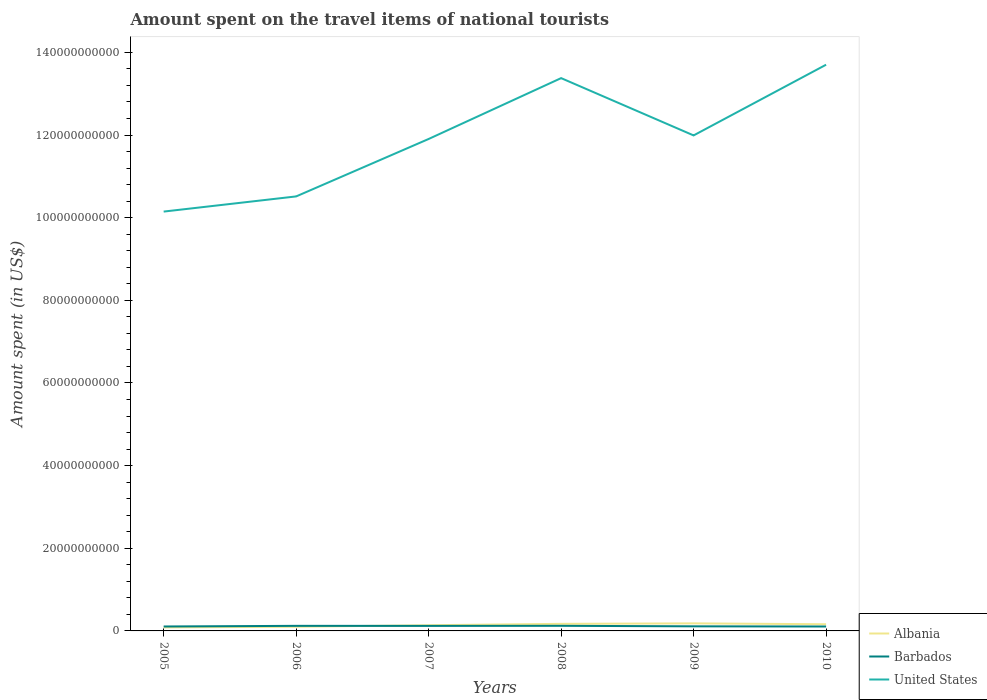Across all years, what is the maximum amount spent on the travel items of national tourists in Barbados?
Make the answer very short. 1.07e+09. In which year was the amount spent on the travel items of national tourists in Barbados maximum?
Offer a terse response. 2010. What is the total amount spent on the travel items of national tourists in Barbados in the graph?
Offer a very short reply. -1.44e+08. What is the difference between the highest and the second highest amount spent on the travel items of national tourists in United States?
Provide a short and direct response. 3.55e+1. How many years are there in the graph?
Your answer should be compact. 6. Does the graph contain any zero values?
Ensure brevity in your answer.  No. How many legend labels are there?
Your answer should be very brief. 3. How are the legend labels stacked?
Keep it short and to the point. Vertical. What is the title of the graph?
Your response must be concise. Amount spent on the travel items of national tourists. What is the label or title of the Y-axis?
Your response must be concise. Amount spent (in US$). What is the Amount spent (in US$) in Albania in 2005?
Make the answer very short. 8.54e+08. What is the Amount spent (in US$) of Barbados in 2005?
Provide a short and direct response. 1.07e+09. What is the Amount spent (in US$) of United States in 2005?
Your response must be concise. 1.01e+11. What is the Amount spent (in US$) of Albania in 2006?
Give a very brief answer. 1.01e+09. What is the Amount spent (in US$) of Barbados in 2006?
Keep it short and to the point. 1.23e+09. What is the Amount spent (in US$) of United States in 2006?
Provide a succinct answer. 1.05e+11. What is the Amount spent (in US$) of Albania in 2007?
Provide a short and direct response. 1.38e+09. What is the Amount spent (in US$) of Barbados in 2007?
Offer a very short reply. 1.22e+09. What is the Amount spent (in US$) in United States in 2007?
Keep it short and to the point. 1.19e+11. What is the Amount spent (in US$) of Albania in 2008?
Ensure brevity in your answer.  1.71e+09. What is the Amount spent (in US$) of Barbados in 2008?
Your answer should be compact. 1.24e+09. What is the Amount spent (in US$) of United States in 2008?
Offer a very short reply. 1.34e+11. What is the Amount spent (in US$) of Albania in 2009?
Offer a terse response. 1.83e+09. What is the Amount spent (in US$) of Barbados in 2009?
Give a very brief answer. 1.11e+09. What is the Amount spent (in US$) in United States in 2009?
Provide a succinct answer. 1.20e+11. What is the Amount spent (in US$) of Albania in 2010?
Your answer should be compact. 1.61e+09. What is the Amount spent (in US$) of Barbados in 2010?
Give a very brief answer. 1.07e+09. What is the Amount spent (in US$) of United States in 2010?
Keep it short and to the point. 1.37e+11. Across all years, what is the maximum Amount spent (in US$) of Albania?
Offer a very short reply. 1.83e+09. Across all years, what is the maximum Amount spent (in US$) in Barbados?
Give a very brief answer. 1.24e+09. Across all years, what is the maximum Amount spent (in US$) of United States?
Make the answer very short. 1.37e+11. Across all years, what is the minimum Amount spent (in US$) of Albania?
Make the answer very short. 8.54e+08. Across all years, what is the minimum Amount spent (in US$) of Barbados?
Provide a succinct answer. 1.07e+09. Across all years, what is the minimum Amount spent (in US$) of United States?
Provide a succinct answer. 1.01e+11. What is the total Amount spent (in US$) of Albania in the graph?
Provide a short and direct response. 8.40e+09. What is the total Amount spent (in US$) of Barbados in the graph?
Ensure brevity in your answer.  6.94e+09. What is the total Amount spent (in US$) in United States in the graph?
Provide a succinct answer. 7.16e+11. What is the difference between the Amount spent (in US$) of Albania in 2005 and that in 2006?
Offer a very short reply. -1.58e+08. What is the difference between the Amount spent (in US$) in Barbados in 2005 and that in 2006?
Offer a terse response. -1.55e+08. What is the difference between the Amount spent (in US$) of United States in 2005 and that in 2006?
Provide a short and direct response. -3.67e+09. What is the difference between the Amount spent (in US$) of Albania in 2005 and that in 2007?
Your answer should be very brief. -5.24e+08. What is the difference between the Amount spent (in US$) of Barbados in 2005 and that in 2007?
Keep it short and to the point. -1.44e+08. What is the difference between the Amount spent (in US$) of United States in 2005 and that in 2007?
Your answer should be very brief. -1.76e+1. What is the difference between the Amount spent (in US$) of Albania in 2005 and that in 2008?
Your response must be concise. -8.59e+08. What is the difference between the Amount spent (in US$) in Barbados in 2005 and that in 2008?
Offer a terse response. -1.64e+08. What is the difference between the Amount spent (in US$) of United States in 2005 and that in 2008?
Give a very brief answer. -3.23e+1. What is the difference between the Amount spent (in US$) in Albania in 2005 and that in 2009?
Keep it short and to the point. -9.75e+08. What is the difference between the Amount spent (in US$) in Barbados in 2005 and that in 2009?
Your answer should be compact. -3.90e+07. What is the difference between the Amount spent (in US$) in United States in 2005 and that in 2009?
Your answer should be very brief. -1.84e+1. What is the difference between the Amount spent (in US$) of Albania in 2005 and that in 2010?
Give a very brief answer. -7.59e+08. What is the difference between the Amount spent (in US$) in United States in 2005 and that in 2010?
Keep it short and to the point. -3.55e+1. What is the difference between the Amount spent (in US$) of Albania in 2006 and that in 2007?
Keep it short and to the point. -3.66e+08. What is the difference between the Amount spent (in US$) in Barbados in 2006 and that in 2007?
Make the answer very short. 1.10e+07. What is the difference between the Amount spent (in US$) in United States in 2006 and that in 2007?
Provide a succinct answer. -1.39e+1. What is the difference between the Amount spent (in US$) of Albania in 2006 and that in 2008?
Your answer should be compact. -7.01e+08. What is the difference between the Amount spent (in US$) in Barbados in 2006 and that in 2008?
Offer a terse response. -9.00e+06. What is the difference between the Amount spent (in US$) in United States in 2006 and that in 2008?
Keep it short and to the point. -2.86e+1. What is the difference between the Amount spent (in US$) in Albania in 2006 and that in 2009?
Keep it short and to the point. -8.17e+08. What is the difference between the Amount spent (in US$) of Barbados in 2006 and that in 2009?
Make the answer very short. 1.16e+08. What is the difference between the Amount spent (in US$) of United States in 2006 and that in 2009?
Give a very brief answer. -1.48e+1. What is the difference between the Amount spent (in US$) of Albania in 2006 and that in 2010?
Make the answer very short. -6.01e+08. What is the difference between the Amount spent (in US$) in Barbados in 2006 and that in 2010?
Your answer should be compact. 1.57e+08. What is the difference between the Amount spent (in US$) in United States in 2006 and that in 2010?
Give a very brief answer. -3.19e+1. What is the difference between the Amount spent (in US$) of Albania in 2007 and that in 2008?
Offer a terse response. -3.35e+08. What is the difference between the Amount spent (in US$) in Barbados in 2007 and that in 2008?
Offer a very short reply. -2.00e+07. What is the difference between the Amount spent (in US$) in United States in 2007 and that in 2008?
Offer a terse response. -1.47e+1. What is the difference between the Amount spent (in US$) in Albania in 2007 and that in 2009?
Provide a short and direct response. -4.51e+08. What is the difference between the Amount spent (in US$) of Barbados in 2007 and that in 2009?
Your response must be concise. 1.05e+08. What is the difference between the Amount spent (in US$) in United States in 2007 and that in 2009?
Give a very brief answer. -8.63e+08. What is the difference between the Amount spent (in US$) of Albania in 2007 and that in 2010?
Ensure brevity in your answer.  -2.35e+08. What is the difference between the Amount spent (in US$) of Barbados in 2007 and that in 2010?
Your answer should be compact. 1.46e+08. What is the difference between the Amount spent (in US$) in United States in 2007 and that in 2010?
Keep it short and to the point. -1.80e+1. What is the difference between the Amount spent (in US$) in Albania in 2008 and that in 2009?
Give a very brief answer. -1.16e+08. What is the difference between the Amount spent (in US$) of Barbados in 2008 and that in 2009?
Ensure brevity in your answer.  1.25e+08. What is the difference between the Amount spent (in US$) of United States in 2008 and that in 2009?
Offer a very short reply. 1.39e+1. What is the difference between the Amount spent (in US$) of Albania in 2008 and that in 2010?
Your answer should be compact. 1.00e+08. What is the difference between the Amount spent (in US$) of Barbados in 2008 and that in 2010?
Keep it short and to the point. 1.66e+08. What is the difference between the Amount spent (in US$) of United States in 2008 and that in 2010?
Keep it short and to the point. -3.24e+09. What is the difference between the Amount spent (in US$) of Albania in 2009 and that in 2010?
Ensure brevity in your answer.  2.16e+08. What is the difference between the Amount spent (in US$) in Barbados in 2009 and that in 2010?
Your response must be concise. 4.10e+07. What is the difference between the Amount spent (in US$) of United States in 2009 and that in 2010?
Make the answer very short. -1.71e+1. What is the difference between the Amount spent (in US$) of Albania in 2005 and the Amount spent (in US$) of Barbados in 2006?
Keep it short and to the point. -3.74e+08. What is the difference between the Amount spent (in US$) of Albania in 2005 and the Amount spent (in US$) of United States in 2006?
Offer a terse response. -1.04e+11. What is the difference between the Amount spent (in US$) in Barbados in 2005 and the Amount spent (in US$) in United States in 2006?
Your response must be concise. -1.04e+11. What is the difference between the Amount spent (in US$) in Albania in 2005 and the Amount spent (in US$) in Barbados in 2007?
Provide a succinct answer. -3.63e+08. What is the difference between the Amount spent (in US$) of Albania in 2005 and the Amount spent (in US$) of United States in 2007?
Provide a succinct answer. -1.18e+11. What is the difference between the Amount spent (in US$) in Barbados in 2005 and the Amount spent (in US$) in United States in 2007?
Make the answer very short. -1.18e+11. What is the difference between the Amount spent (in US$) in Albania in 2005 and the Amount spent (in US$) in Barbados in 2008?
Your response must be concise. -3.83e+08. What is the difference between the Amount spent (in US$) of Albania in 2005 and the Amount spent (in US$) of United States in 2008?
Your answer should be compact. -1.33e+11. What is the difference between the Amount spent (in US$) of Barbados in 2005 and the Amount spent (in US$) of United States in 2008?
Provide a succinct answer. -1.33e+11. What is the difference between the Amount spent (in US$) in Albania in 2005 and the Amount spent (in US$) in Barbados in 2009?
Offer a terse response. -2.58e+08. What is the difference between the Amount spent (in US$) in Albania in 2005 and the Amount spent (in US$) in United States in 2009?
Make the answer very short. -1.19e+11. What is the difference between the Amount spent (in US$) in Barbados in 2005 and the Amount spent (in US$) in United States in 2009?
Provide a succinct answer. -1.19e+11. What is the difference between the Amount spent (in US$) of Albania in 2005 and the Amount spent (in US$) of Barbados in 2010?
Provide a succinct answer. -2.17e+08. What is the difference between the Amount spent (in US$) of Albania in 2005 and the Amount spent (in US$) of United States in 2010?
Offer a terse response. -1.36e+11. What is the difference between the Amount spent (in US$) in Barbados in 2005 and the Amount spent (in US$) in United States in 2010?
Provide a short and direct response. -1.36e+11. What is the difference between the Amount spent (in US$) in Albania in 2006 and the Amount spent (in US$) in Barbados in 2007?
Keep it short and to the point. -2.05e+08. What is the difference between the Amount spent (in US$) of Albania in 2006 and the Amount spent (in US$) of United States in 2007?
Provide a succinct answer. -1.18e+11. What is the difference between the Amount spent (in US$) in Barbados in 2006 and the Amount spent (in US$) in United States in 2007?
Provide a succinct answer. -1.18e+11. What is the difference between the Amount spent (in US$) of Albania in 2006 and the Amount spent (in US$) of Barbados in 2008?
Give a very brief answer. -2.25e+08. What is the difference between the Amount spent (in US$) of Albania in 2006 and the Amount spent (in US$) of United States in 2008?
Make the answer very short. -1.33e+11. What is the difference between the Amount spent (in US$) in Barbados in 2006 and the Amount spent (in US$) in United States in 2008?
Your answer should be compact. -1.33e+11. What is the difference between the Amount spent (in US$) in Albania in 2006 and the Amount spent (in US$) in Barbados in 2009?
Provide a succinct answer. -1.00e+08. What is the difference between the Amount spent (in US$) in Albania in 2006 and the Amount spent (in US$) in United States in 2009?
Make the answer very short. -1.19e+11. What is the difference between the Amount spent (in US$) in Barbados in 2006 and the Amount spent (in US$) in United States in 2009?
Give a very brief answer. -1.19e+11. What is the difference between the Amount spent (in US$) of Albania in 2006 and the Amount spent (in US$) of Barbados in 2010?
Keep it short and to the point. -5.90e+07. What is the difference between the Amount spent (in US$) of Albania in 2006 and the Amount spent (in US$) of United States in 2010?
Provide a short and direct response. -1.36e+11. What is the difference between the Amount spent (in US$) of Barbados in 2006 and the Amount spent (in US$) of United States in 2010?
Ensure brevity in your answer.  -1.36e+11. What is the difference between the Amount spent (in US$) of Albania in 2007 and the Amount spent (in US$) of Barbados in 2008?
Ensure brevity in your answer.  1.41e+08. What is the difference between the Amount spent (in US$) in Albania in 2007 and the Amount spent (in US$) in United States in 2008?
Make the answer very short. -1.32e+11. What is the difference between the Amount spent (in US$) of Barbados in 2007 and the Amount spent (in US$) of United States in 2008?
Make the answer very short. -1.33e+11. What is the difference between the Amount spent (in US$) in Albania in 2007 and the Amount spent (in US$) in Barbados in 2009?
Give a very brief answer. 2.66e+08. What is the difference between the Amount spent (in US$) in Albania in 2007 and the Amount spent (in US$) in United States in 2009?
Your answer should be very brief. -1.19e+11. What is the difference between the Amount spent (in US$) in Barbados in 2007 and the Amount spent (in US$) in United States in 2009?
Your response must be concise. -1.19e+11. What is the difference between the Amount spent (in US$) in Albania in 2007 and the Amount spent (in US$) in Barbados in 2010?
Offer a very short reply. 3.07e+08. What is the difference between the Amount spent (in US$) in Albania in 2007 and the Amount spent (in US$) in United States in 2010?
Your answer should be very brief. -1.36e+11. What is the difference between the Amount spent (in US$) in Barbados in 2007 and the Amount spent (in US$) in United States in 2010?
Offer a very short reply. -1.36e+11. What is the difference between the Amount spent (in US$) of Albania in 2008 and the Amount spent (in US$) of Barbados in 2009?
Make the answer very short. 6.01e+08. What is the difference between the Amount spent (in US$) of Albania in 2008 and the Amount spent (in US$) of United States in 2009?
Your answer should be very brief. -1.18e+11. What is the difference between the Amount spent (in US$) of Barbados in 2008 and the Amount spent (in US$) of United States in 2009?
Your answer should be very brief. -1.19e+11. What is the difference between the Amount spent (in US$) in Albania in 2008 and the Amount spent (in US$) in Barbados in 2010?
Your response must be concise. 6.42e+08. What is the difference between the Amount spent (in US$) of Albania in 2008 and the Amount spent (in US$) of United States in 2010?
Offer a terse response. -1.35e+11. What is the difference between the Amount spent (in US$) in Barbados in 2008 and the Amount spent (in US$) in United States in 2010?
Provide a succinct answer. -1.36e+11. What is the difference between the Amount spent (in US$) of Albania in 2009 and the Amount spent (in US$) of Barbados in 2010?
Keep it short and to the point. 7.58e+08. What is the difference between the Amount spent (in US$) of Albania in 2009 and the Amount spent (in US$) of United States in 2010?
Make the answer very short. -1.35e+11. What is the difference between the Amount spent (in US$) of Barbados in 2009 and the Amount spent (in US$) of United States in 2010?
Ensure brevity in your answer.  -1.36e+11. What is the average Amount spent (in US$) of Albania per year?
Provide a succinct answer. 1.40e+09. What is the average Amount spent (in US$) in Barbados per year?
Your answer should be compact. 1.16e+09. What is the average Amount spent (in US$) in United States per year?
Provide a succinct answer. 1.19e+11. In the year 2005, what is the difference between the Amount spent (in US$) in Albania and Amount spent (in US$) in Barbados?
Make the answer very short. -2.19e+08. In the year 2005, what is the difference between the Amount spent (in US$) in Albania and Amount spent (in US$) in United States?
Provide a succinct answer. -1.01e+11. In the year 2005, what is the difference between the Amount spent (in US$) in Barbados and Amount spent (in US$) in United States?
Keep it short and to the point. -1.00e+11. In the year 2006, what is the difference between the Amount spent (in US$) in Albania and Amount spent (in US$) in Barbados?
Your response must be concise. -2.16e+08. In the year 2006, what is the difference between the Amount spent (in US$) in Albania and Amount spent (in US$) in United States?
Provide a short and direct response. -1.04e+11. In the year 2006, what is the difference between the Amount spent (in US$) of Barbados and Amount spent (in US$) of United States?
Provide a short and direct response. -1.04e+11. In the year 2007, what is the difference between the Amount spent (in US$) of Albania and Amount spent (in US$) of Barbados?
Make the answer very short. 1.61e+08. In the year 2007, what is the difference between the Amount spent (in US$) in Albania and Amount spent (in US$) in United States?
Your answer should be compact. -1.18e+11. In the year 2007, what is the difference between the Amount spent (in US$) in Barbados and Amount spent (in US$) in United States?
Your response must be concise. -1.18e+11. In the year 2008, what is the difference between the Amount spent (in US$) of Albania and Amount spent (in US$) of Barbados?
Your answer should be very brief. 4.76e+08. In the year 2008, what is the difference between the Amount spent (in US$) of Albania and Amount spent (in US$) of United States?
Your answer should be compact. -1.32e+11. In the year 2008, what is the difference between the Amount spent (in US$) in Barbados and Amount spent (in US$) in United States?
Ensure brevity in your answer.  -1.33e+11. In the year 2009, what is the difference between the Amount spent (in US$) of Albania and Amount spent (in US$) of Barbados?
Your answer should be very brief. 7.17e+08. In the year 2009, what is the difference between the Amount spent (in US$) in Albania and Amount spent (in US$) in United States?
Offer a terse response. -1.18e+11. In the year 2009, what is the difference between the Amount spent (in US$) of Barbados and Amount spent (in US$) of United States?
Provide a short and direct response. -1.19e+11. In the year 2010, what is the difference between the Amount spent (in US$) of Albania and Amount spent (in US$) of Barbados?
Your answer should be compact. 5.42e+08. In the year 2010, what is the difference between the Amount spent (in US$) in Albania and Amount spent (in US$) in United States?
Keep it short and to the point. -1.35e+11. In the year 2010, what is the difference between the Amount spent (in US$) in Barbados and Amount spent (in US$) in United States?
Offer a very short reply. -1.36e+11. What is the ratio of the Amount spent (in US$) in Albania in 2005 to that in 2006?
Provide a short and direct response. 0.84. What is the ratio of the Amount spent (in US$) in Barbados in 2005 to that in 2006?
Provide a short and direct response. 0.87. What is the ratio of the Amount spent (in US$) in United States in 2005 to that in 2006?
Make the answer very short. 0.97. What is the ratio of the Amount spent (in US$) in Albania in 2005 to that in 2007?
Your answer should be very brief. 0.62. What is the ratio of the Amount spent (in US$) of Barbados in 2005 to that in 2007?
Provide a short and direct response. 0.88. What is the ratio of the Amount spent (in US$) of United States in 2005 to that in 2007?
Keep it short and to the point. 0.85. What is the ratio of the Amount spent (in US$) in Albania in 2005 to that in 2008?
Ensure brevity in your answer.  0.5. What is the ratio of the Amount spent (in US$) in Barbados in 2005 to that in 2008?
Your answer should be compact. 0.87. What is the ratio of the Amount spent (in US$) of United States in 2005 to that in 2008?
Ensure brevity in your answer.  0.76. What is the ratio of the Amount spent (in US$) of Albania in 2005 to that in 2009?
Keep it short and to the point. 0.47. What is the ratio of the Amount spent (in US$) in Barbados in 2005 to that in 2009?
Make the answer very short. 0.96. What is the ratio of the Amount spent (in US$) of United States in 2005 to that in 2009?
Ensure brevity in your answer.  0.85. What is the ratio of the Amount spent (in US$) of Albania in 2005 to that in 2010?
Offer a very short reply. 0.53. What is the ratio of the Amount spent (in US$) of United States in 2005 to that in 2010?
Provide a short and direct response. 0.74. What is the ratio of the Amount spent (in US$) of Albania in 2006 to that in 2007?
Your answer should be compact. 0.73. What is the ratio of the Amount spent (in US$) in Barbados in 2006 to that in 2007?
Provide a succinct answer. 1.01. What is the ratio of the Amount spent (in US$) in United States in 2006 to that in 2007?
Ensure brevity in your answer.  0.88. What is the ratio of the Amount spent (in US$) in Albania in 2006 to that in 2008?
Provide a succinct answer. 0.59. What is the ratio of the Amount spent (in US$) in Barbados in 2006 to that in 2008?
Provide a short and direct response. 0.99. What is the ratio of the Amount spent (in US$) in United States in 2006 to that in 2008?
Provide a succinct answer. 0.79. What is the ratio of the Amount spent (in US$) in Albania in 2006 to that in 2009?
Provide a short and direct response. 0.55. What is the ratio of the Amount spent (in US$) in Barbados in 2006 to that in 2009?
Your answer should be very brief. 1.1. What is the ratio of the Amount spent (in US$) in United States in 2006 to that in 2009?
Offer a very short reply. 0.88. What is the ratio of the Amount spent (in US$) in Albania in 2006 to that in 2010?
Provide a succinct answer. 0.63. What is the ratio of the Amount spent (in US$) of Barbados in 2006 to that in 2010?
Provide a short and direct response. 1.15. What is the ratio of the Amount spent (in US$) in United States in 2006 to that in 2010?
Your answer should be very brief. 0.77. What is the ratio of the Amount spent (in US$) of Albania in 2007 to that in 2008?
Keep it short and to the point. 0.8. What is the ratio of the Amount spent (in US$) in Barbados in 2007 to that in 2008?
Your answer should be compact. 0.98. What is the ratio of the Amount spent (in US$) in United States in 2007 to that in 2008?
Make the answer very short. 0.89. What is the ratio of the Amount spent (in US$) in Albania in 2007 to that in 2009?
Your answer should be very brief. 0.75. What is the ratio of the Amount spent (in US$) of Barbados in 2007 to that in 2009?
Keep it short and to the point. 1.09. What is the ratio of the Amount spent (in US$) in Albania in 2007 to that in 2010?
Your answer should be very brief. 0.85. What is the ratio of the Amount spent (in US$) in Barbados in 2007 to that in 2010?
Ensure brevity in your answer.  1.14. What is the ratio of the Amount spent (in US$) in United States in 2007 to that in 2010?
Your answer should be compact. 0.87. What is the ratio of the Amount spent (in US$) of Albania in 2008 to that in 2009?
Offer a very short reply. 0.94. What is the ratio of the Amount spent (in US$) of Barbados in 2008 to that in 2009?
Keep it short and to the point. 1.11. What is the ratio of the Amount spent (in US$) of United States in 2008 to that in 2009?
Offer a very short reply. 1.12. What is the ratio of the Amount spent (in US$) of Albania in 2008 to that in 2010?
Make the answer very short. 1.06. What is the ratio of the Amount spent (in US$) in Barbados in 2008 to that in 2010?
Your answer should be very brief. 1.16. What is the ratio of the Amount spent (in US$) in United States in 2008 to that in 2010?
Make the answer very short. 0.98. What is the ratio of the Amount spent (in US$) of Albania in 2009 to that in 2010?
Offer a very short reply. 1.13. What is the ratio of the Amount spent (in US$) of Barbados in 2009 to that in 2010?
Your response must be concise. 1.04. What is the ratio of the Amount spent (in US$) of United States in 2009 to that in 2010?
Your response must be concise. 0.88. What is the difference between the highest and the second highest Amount spent (in US$) in Albania?
Provide a succinct answer. 1.16e+08. What is the difference between the highest and the second highest Amount spent (in US$) in Barbados?
Provide a short and direct response. 9.00e+06. What is the difference between the highest and the second highest Amount spent (in US$) in United States?
Give a very brief answer. 3.24e+09. What is the difference between the highest and the lowest Amount spent (in US$) in Albania?
Make the answer very short. 9.75e+08. What is the difference between the highest and the lowest Amount spent (in US$) of Barbados?
Offer a terse response. 1.66e+08. What is the difference between the highest and the lowest Amount spent (in US$) in United States?
Your answer should be compact. 3.55e+1. 